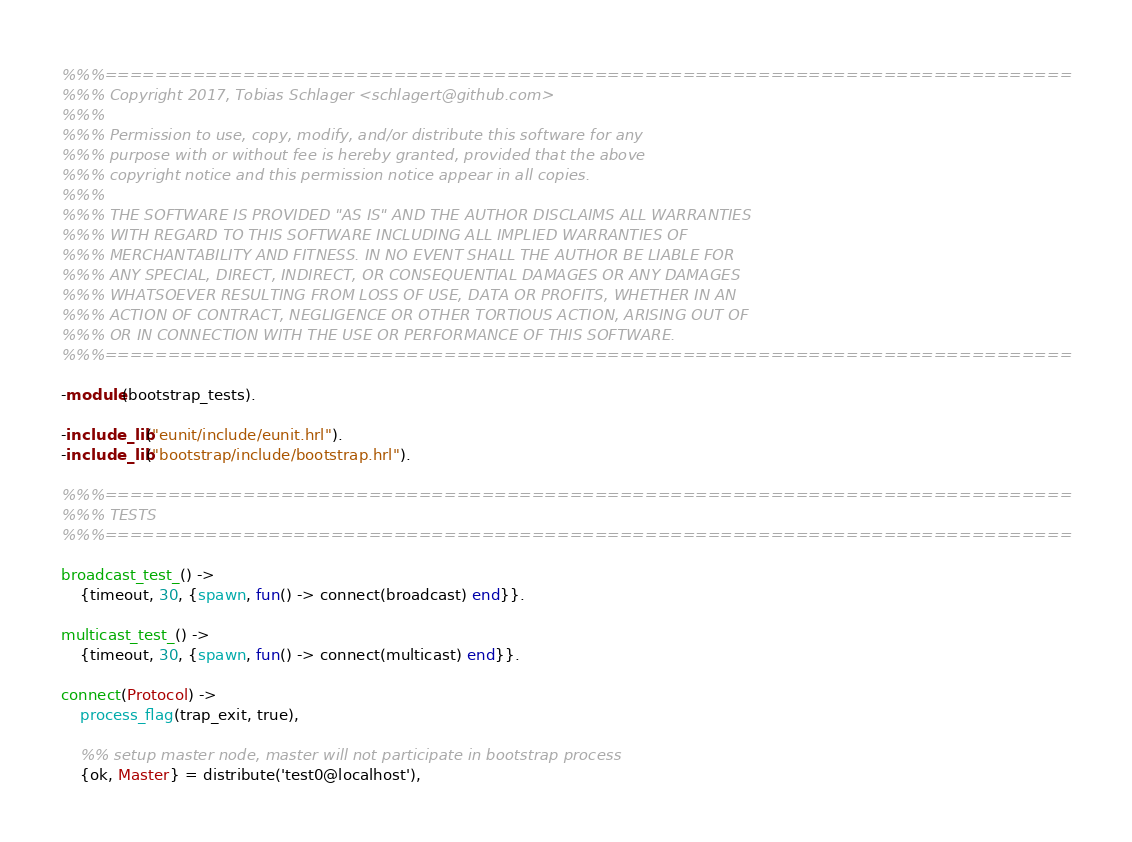<code> <loc_0><loc_0><loc_500><loc_500><_Erlang_>%%%=============================================================================
%%% Copyright 2017, Tobias Schlager <schlagert@github.com>
%%%
%%% Permission to use, copy, modify, and/or distribute this software for any
%%% purpose with or without fee is hereby granted, provided that the above
%%% copyright notice and this permission notice appear in all copies.
%%%
%%% THE SOFTWARE IS PROVIDED "AS IS" AND THE AUTHOR DISCLAIMS ALL WARRANTIES
%%% WITH REGARD TO THIS SOFTWARE INCLUDING ALL IMPLIED WARRANTIES OF
%%% MERCHANTABILITY AND FITNESS. IN NO EVENT SHALL THE AUTHOR BE LIABLE FOR
%%% ANY SPECIAL, DIRECT, INDIRECT, OR CONSEQUENTIAL DAMAGES OR ANY DAMAGES
%%% WHATSOEVER RESULTING FROM LOSS OF USE, DATA OR PROFITS, WHETHER IN AN
%%% ACTION OF CONTRACT, NEGLIGENCE OR OTHER TORTIOUS ACTION, ARISING OUT OF
%%% OR IN CONNECTION WITH THE USE OR PERFORMANCE OF THIS SOFTWARE.
%%%=============================================================================

-module(bootstrap_tests).

-include_lib("eunit/include/eunit.hrl").
-include_lib("bootstrap/include/bootstrap.hrl").

%%%=============================================================================
%%% TESTS
%%%=============================================================================

broadcast_test_() ->
    {timeout, 30, {spawn, fun() -> connect(broadcast) end}}.

multicast_test_() ->
    {timeout, 30, {spawn, fun() -> connect(multicast) end}}.

connect(Protocol) ->
    process_flag(trap_exit, true),

    %% setup master node, master will not participate in bootstrap process
    {ok, Master} = distribute('test0@localhost'),
</code> 